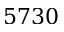Convert formula to latex. <formula><loc_0><loc_0><loc_500><loc_500>5 7 3 0</formula> 